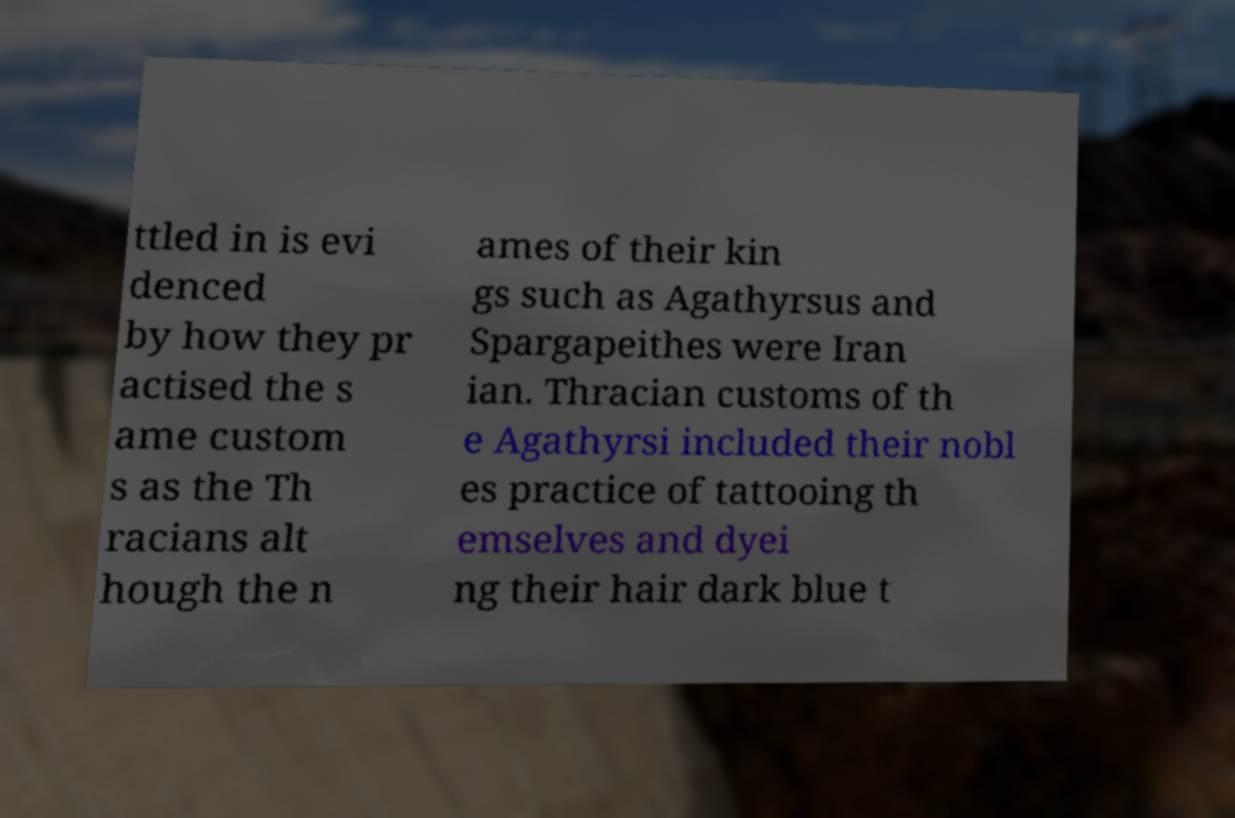There's text embedded in this image that I need extracted. Can you transcribe it verbatim? ttled in is evi denced by how they pr actised the s ame custom s as the Th racians alt hough the n ames of their kin gs such as Agathyrsus and Spargapeithes were Iran ian. Thracian customs of th e Agathyrsi included their nobl es practice of tattooing th emselves and dyei ng their hair dark blue t 